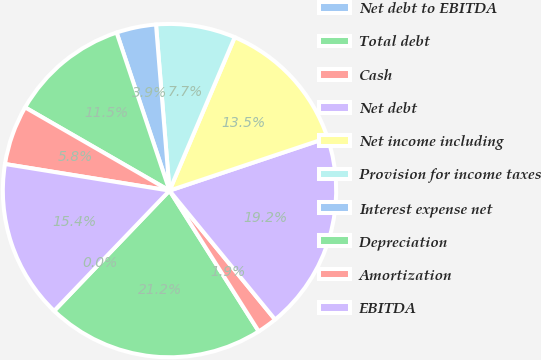Convert chart. <chart><loc_0><loc_0><loc_500><loc_500><pie_chart><fcel>Net debt to EBITDA<fcel>Total debt<fcel>Cash<fcel>Net debt<fcel>Net income including<fcel>Provision for income taxes<fcel>Interest expense net<fcel>Depreciation<fcel>Amortization<fcel>EBITDA<nl><fcel>0.01%<fcel>21.15%<fcel>1.93%<fcel>19.22%<fcel>13.46%<fcel>7.69%<fcel>3.85%<fcel>11.54%<fcel>5.77%<fcel>15.38%<nl></chart> 